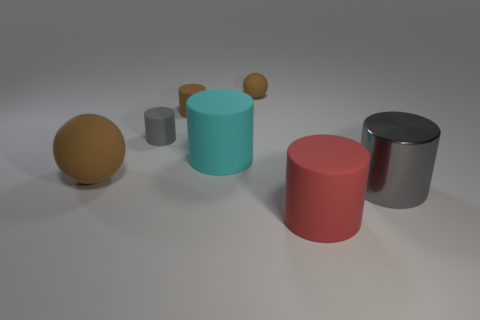Subtract all red balls. How many gray cylinders are left? 2 Subtract all small cylinders. How many cylinders are left? 3 Subtract all cyan cylinders. How many cylinders are left? 4 Add 1 tiny cyan rubber spheres. How many objects exist? 8 Subtract all cylinders. How many objects are left? 2 Add 1 large red rubber things. How many large red rubber things are left? 2 Add 4 cyan cylinders. How many cyan cylinders exist? 5 Subtract 0 purple balls. How many objects are left? 7 Subtract all brown cylinders. Subtract all purple balls. How many cylinders are left? 4 Subtract all big cylinders. Subtract all tiny purple matte cylinders. How many objects are left? 4 